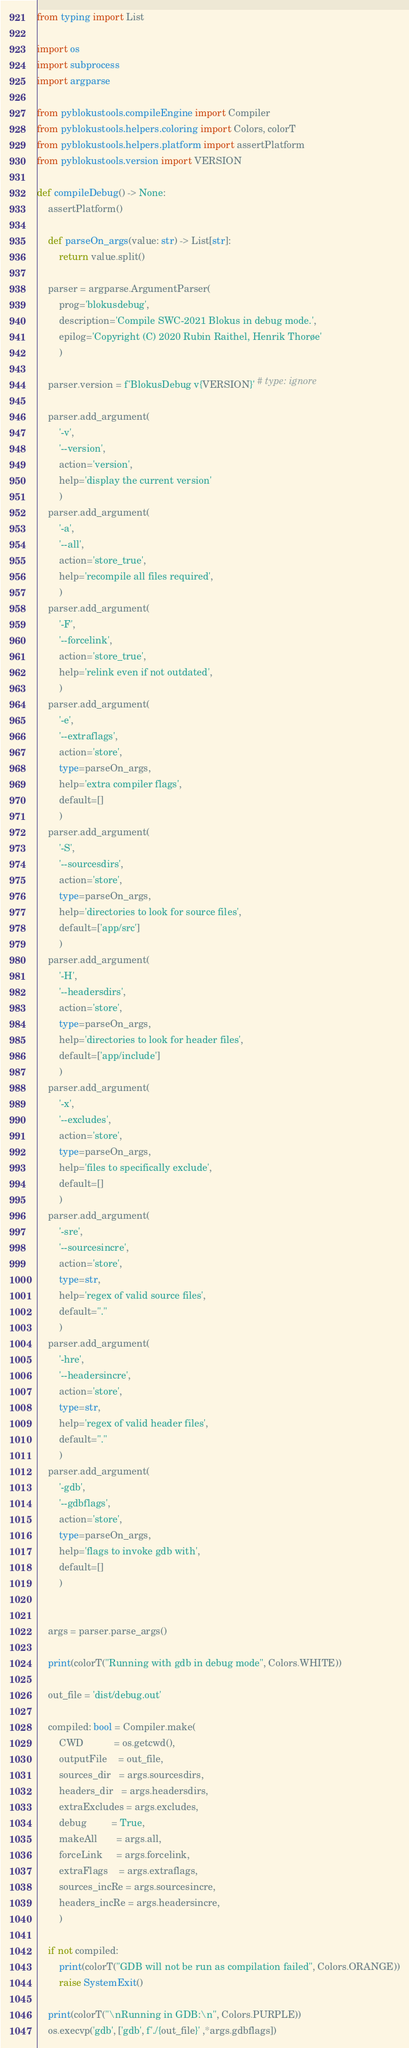Convert code to text. <code><loc_0><loc_0><loc_500><loc_500><_Python_>from typing import List

import os
import subprocess
import argparse

from pyblokustools.compileEngine import Compiler
from pyblokustools.helpers.coloring import Colors, colorT
from pyblokustools.helpers.platform import assertPlatform
from pyblokustools.version import VERSION

def compileDebug() -> None:
    assertPlatform()
    
    def parseOn_args(value: str) -> List[str]:
        return value.split()
    
    parser = argparse.ArgumentParser(
        prog='blokusdebug',
        description='Compile SWC-2021 Blokus in debug mode.',
        epilog='Copyright (C) 2020 Rubin Raithel, Henrik Thorøe'
        )
    
    parser.version = f'BlokusDebug v{VERSION}' # type: ignore
    
    parser.add_argument(
        '-v',
        '--version',
        action='version',
        help='display the current version'
        )
    parser.add_argument(
        '-a',
        '--all',
        action='store_true',
        help='recompile all files required',
        )
    parser.add_argument(
        '-F',
        '--forcelink',
        action='store_true',
        help='relink even if not outdated',
        )
    parser.add_argument(
        '-e',
        '--extraflags',
        action='store',
        type=parseOn_args,
        help='extra compiler flags',
        default=[]
        )
    parser.add_argument(
        '-S',
        '--sourcesdirs',
        action='store',
        type=parseOn_args,
        help='directories to look for source files',
        default=['app/src']
        )
    parser.add_argument(
        '-H',
        '--headersdirs',
        action='store',
        type=parseOn_args,
        help='directories to look for header files',
        default=['app/include']
        )
    parser.add_argument(
        '-x',
        '--excludes',
        action='store',
        type=parseOn_args,
        help='files to specifically exclude',
        default=[]
        )
    parser.add_argument(
        '-sre',
        '--sourcesincre',
        action='store',
        type=str,
        help='regex of valid source files',
        default="."
        )
    parser.add_argument(
        '-hre',
        '--headersincre',
        action='store',
        type=str,
        help='regex of valid header files',
        default="."
        )
    parser.add_argument(
        '-gdb',
        '--gdbflags',
        action='store',
        type=parseOn_args,
        help='flags to invoke gdb with',
        default=[]
        )
    
    
    args = parser.parse_args()

    print(colorT("Running with gdb in debug mode", Colors.WHITE))

    out_file = 'dist/debug.out'

    compiled: bool = Compiler.make(
        CWD           = os.getcwd(),
        outputFile    = out_file,
        sources_dir   = args.sourcesdirs,
        headers_dir   = args.headersdirs,
        extraExcludes = args.excludes,
        debug         = True,
        makeAll       = args.all,
        forceLink     = args.forcelink,
        extraFlags    = args.extraflags,
        sources_incRe = args.sourcesincre,
        headers_incRe = args.headersincre,
        )

    if not compiled:
        print(colorT("GDB will not be run as compilation failed", Colors.ORANGE))
        raise SystemExit()

    print(colorT("\nRunning in GDB:\n", Colors.PURPLE))
    os.execvp('gdb', ['gdb', f'./{out_file}' ,*args.gdbflags])
</code> 